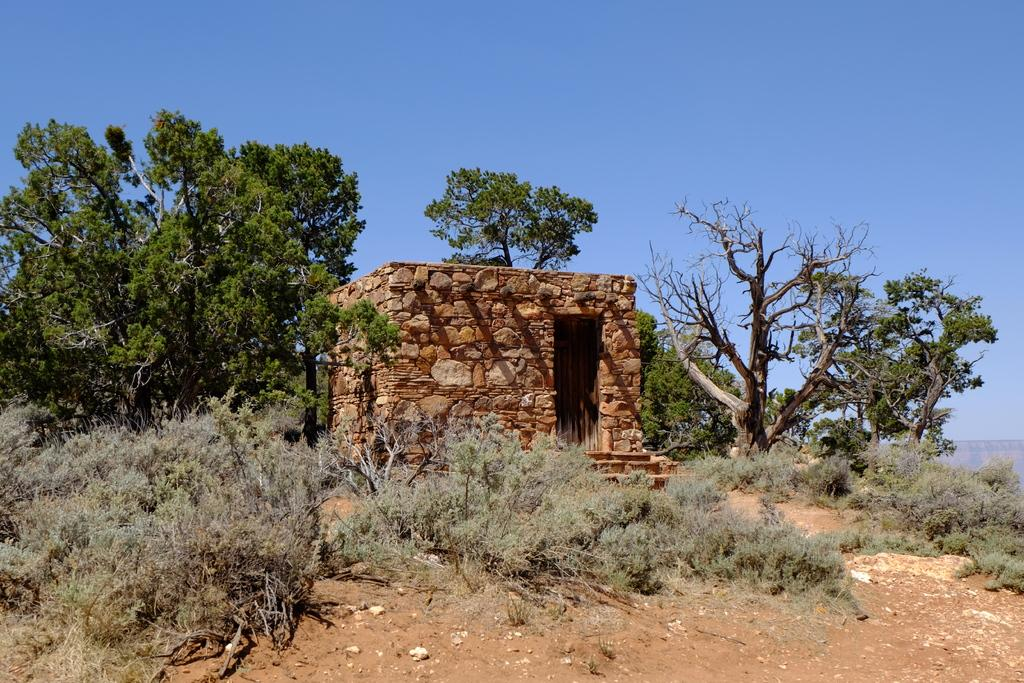What is located in the center of the picture? There are shrubs, trees, and stone walls in the center of the picture. What type of vegetation can be seen in the center of the picture? Both shrubs and trees are visible in the center of the picture. What is the material of the walls in the center of the picture? The walls are made of stone. What can be seen in the foreground of the picture? There is soil in the foreground of the picture. What is visible at the top of the picture? The sky is visible at the top of the picture. What is the weather like in the image? The sky is sunny, indicating a clear and bright day. What type of income can be seen in the image? There is no income visible in the image; it features natural elements such as shrubs, trees, stone walls, soil, and the sky. Is there a veil covering any part of the image? There is no veil present in the image. 